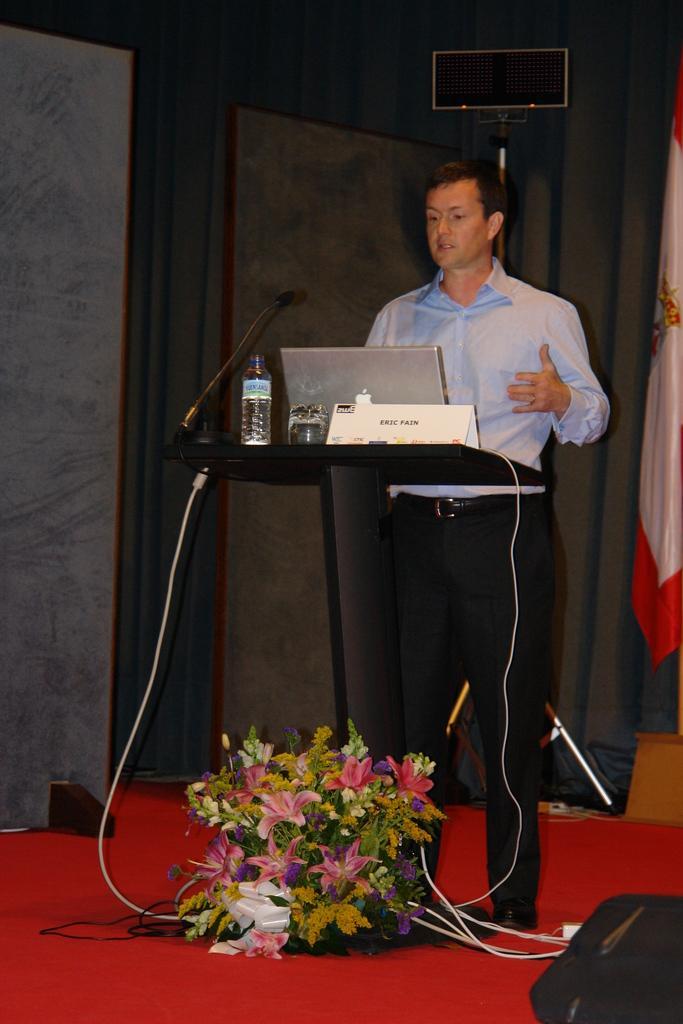Describe this image in one or two sentences. In this picture there is a man who is standing on the right side of the image, in front of a desk, on which there is a laptop and a water bottle, there are flowers at the bottom side of the image, there is a flag on the right side of the image. 